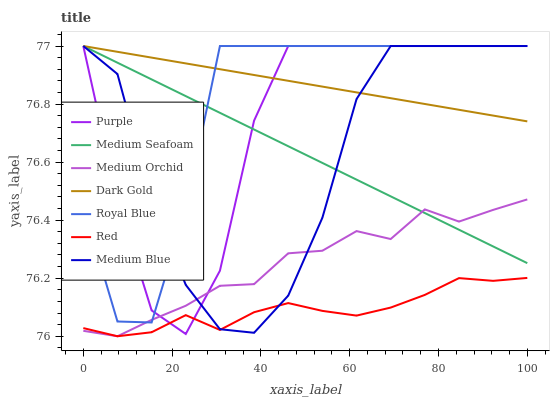Does Red have the minimum area under the curve?
Answer yes or no. Yes. Does Dark Gold have the maximum area under the curve?
Answer yes or no. Yes. Does Purple have the minimum area under the curve?
Answer yes or no. No. Does Purple have the maximum area under the curve?
Answer yes or no. No. Is Dark Gold the smoothest?
Answer yes or no. Yes. Is Medium Blue the roughest?
Answer yes or no. Yes. Is Purple the smoothest?
Answer yes or no. No. Is Purple the roughest?
Answer yes or no. No. Does Medium Orchid have the lowest value?
Answer yes or no. Yes. Does Purple have the lowest value?
Answer yes or no. No. Does Medium Seafoam have the highest value?
Answer yes or no. Yes. Does Medium Orchid have the highest value?
Answer yes or no. No. Is Red less than Medium Seafoam?
Answer yes or no. Yes. Is Medium Seafoam greater than Red?
Answer yes or no. Yes. Does Medium Seafoam intersect Purple?
Answer yes or no. Yes. Is Medium Seafoam less than Purple?
Answer yes or no. No. Is Medium Seafoam greater than Purple?
Answer yes or no. No. Does Red intersect Medium Seafoam?
Answer yes or no. No. 